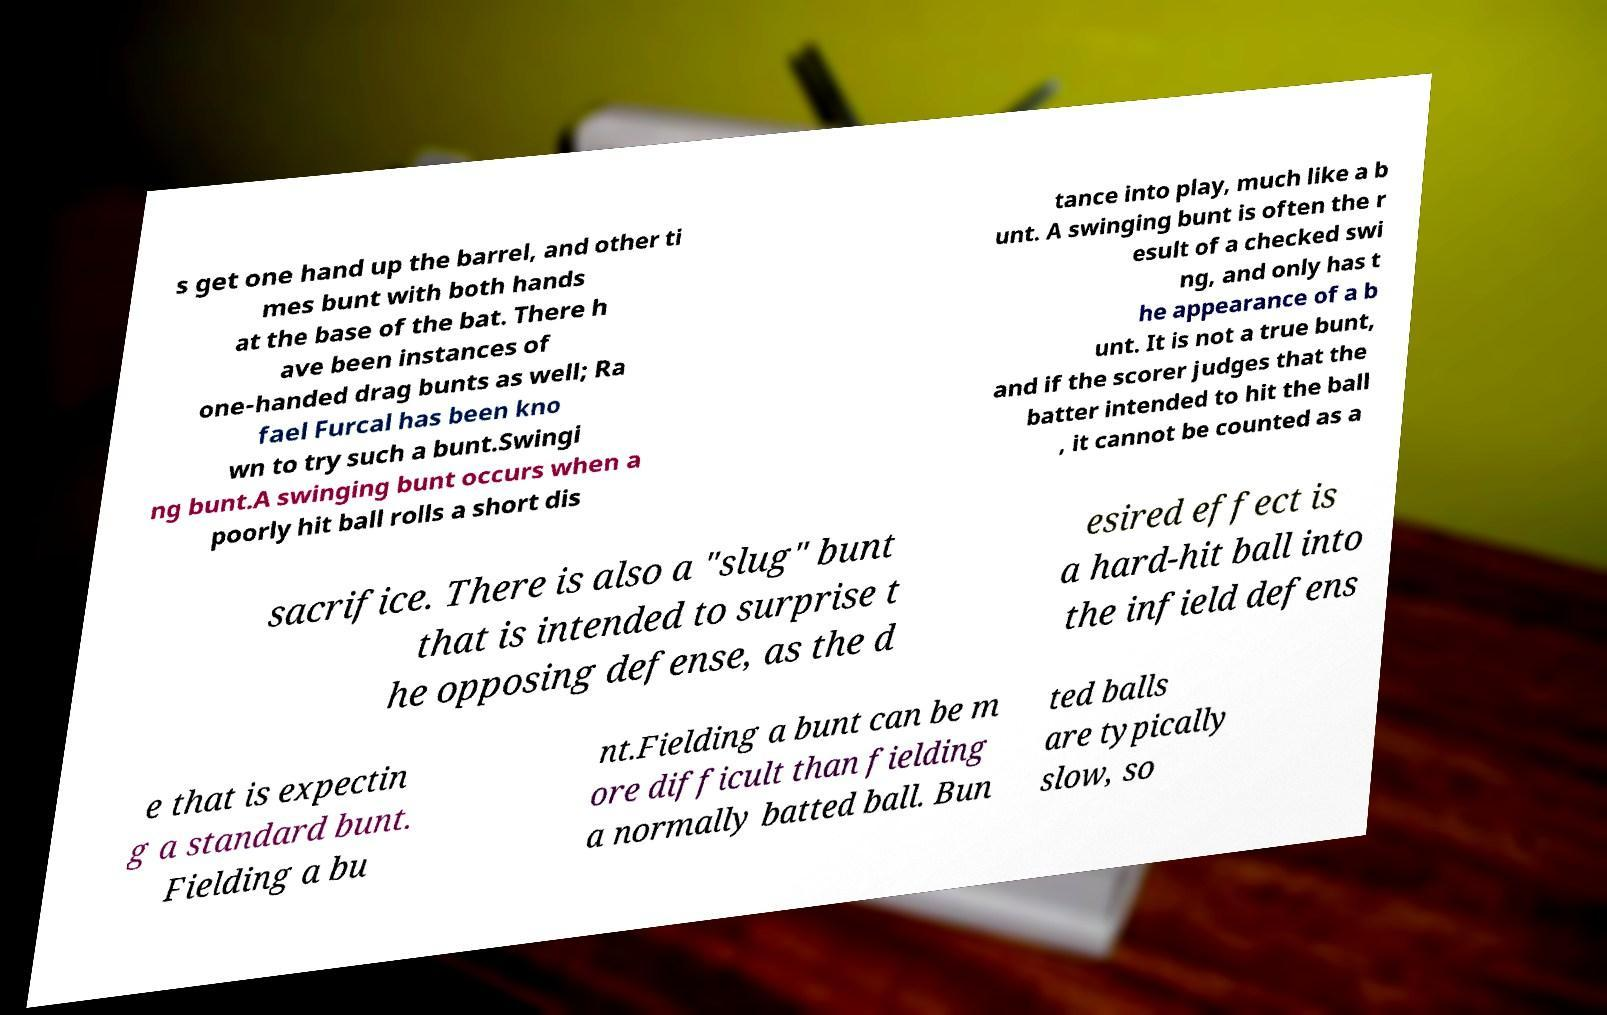Can you accurately transcribe the text from the provided image for me? s get one hand up the barrel, and other ti mes bunt with both hands at the base of the bat. There h ave been instances of one-handed drag bunts as well; Ra fael Furcal has been kno wn to try such a bunt.Swingi ng bunt.A swinging bunt occurs when a poorly hit ball rolls a short dis tance into play, much like a b unt. A swinging bunt is often the r esult of a checked swi ng, and only has t he appearance of a b unt. It is not a true bunt, and if the scorer judges that the batter intended to hit the ball , it cannot be counted as a sacrifice. There is also a "slug" bunt that is intended to surprise t he opposing defense, as the d esired effect is a hard-hit ball into the infield defens e that is expectin g a standard bunt. Fielding a bu nt.Fielding a bunt can be m ore difficult than fielding a normally batted ball. Bun ted balls are typically slow, so 